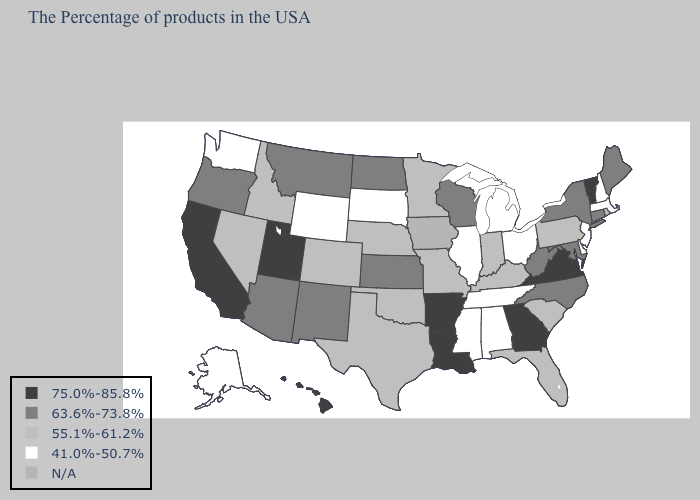What is the value of Connecticut?
Concise answer only. 63.6%-73.8%. Does Alaska have the lowest value in the West?
Answer briefly. Yes. Name the states that have a value in the range 41.0%-50.7%?
Answer briefly. Massachusetts, New Hampshire, New Jersey, Delaware, Ohio, Michigan, Alabama, Tennessee, Illinois, Mississippi, South Dakota, Wyoming, Washington, Alaska. Among the states that border Minnesota , does South Dakota have the lowest value?
Quick response, please. Yes. Name the states that have a value in the range 63.6%-73.8%?
Keep it brief. Maine, Connecticut, New York, Maryland, North Carolina, West Virginia, Wisconsin, Kansas, North Dakota, New Mexico, Montana, Arizona, Oregon. Which states hav the highest value in the South?
Concise answer only. Virginia, Georgia, Louisiana, Arkansas. Does Minnesota have the highest value in the USA?
Be succinct. No. Does Delaware have the lowest value in the South?
Give a very brief answer. Yes. What is the value of New Hampshire?
Short answer required. 41.0%-50.7%. Name the states that have a value in the range N/A?
Quick response, please. Iowa. Name the states that have a value in the range 55.1%-61.2%?
Give a very brief answer. Rhode Island, Pennsylvania, South Carolina, Florida, Kentucky, Indiana, Missouri, Minnesota, Nebraska, Oklahoma, Texas, Colorado, Idaho, Nevada. Name the states that have a value in the range 75.0%-85.8%?
Quick response, please. Vermont, Virginia, Georgia, Louisiana, Arkansas, Utah, California, Hawaii. Which states have the lowest value in the USA?
Short answer required. Massachusetts, New Hampshire, New Jersey, Delaware, Ohio, Michigan, Alabama, Tennessee, Illinois, Mississippi, South Dakota, Wyoming, Washington, Alaska. Name the states that have a value in the range N/A?
Be succinct. Iowa. 